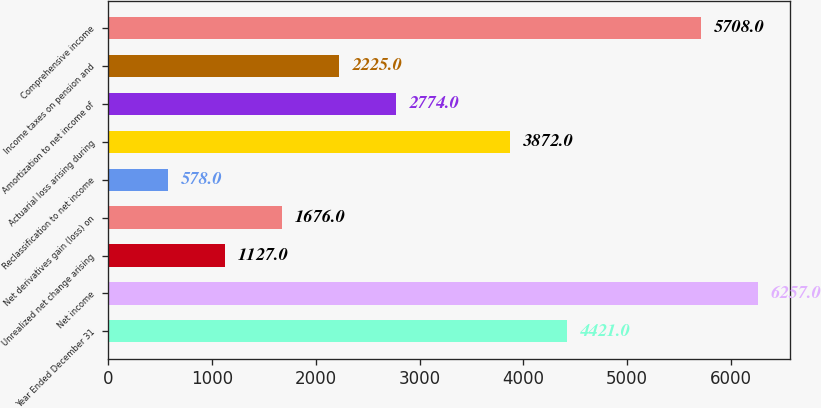Convert chart. <chart><loc_0><loc_0><loc_500><loc_500><bar_chart><fcel>Year Ended December 31<fcel>Net income<fcel>Unrealized net change arising<fcel>Net derivatives gain (loss) on<fcel>Reclassification to net income<fcel>Actuarial loss arising during<fcel>Amortization to net income of<fcel>Income taxes on pension and<fcel>Comprehensive income<nl><fcel>4421<fcel>6257<fcel>1127<fcel>1676<fcel>578<fcel>3872<fcel>2774<fcel>2225<fcel>5708<nl></chart> 